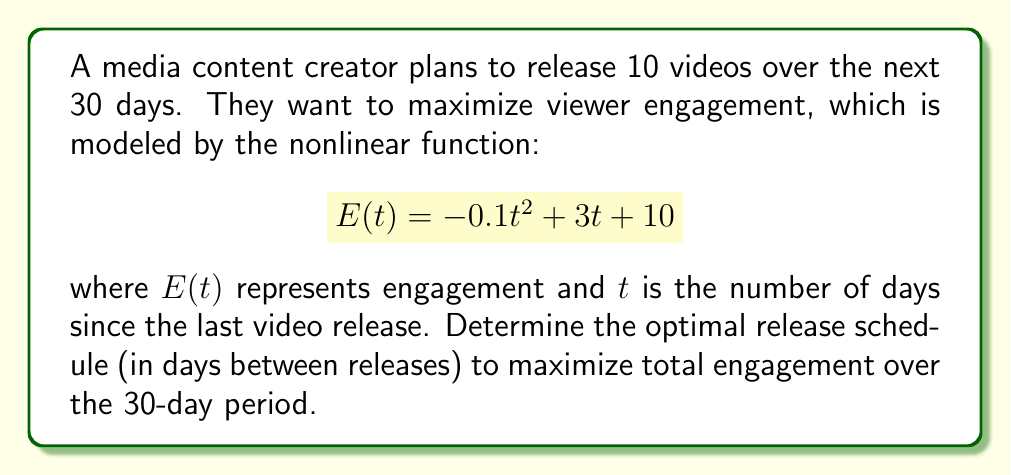Show me your answer to this math problem. 1) First, we need to set up the optimization problem. We want to maximize the total engagement over 30 days:

   $$\text{Maximize } \sum_{i=1}^{10} E(t_i)$$

   where $t_i$ is the number of days between releases, and $\sum_{i=1}^{10} t_i = 30$

2) The engagement function for each release is:

   $$E(t_i) = -0.1t_i^2 + 3t_i + 10$$

3) To find the maximum of this function, we differentiate and set to zero:

   $$\frac{dE}{dt_i} = -0.2t_i + 3 = 0$$
   $$t_i = 15$$

4) This means that the optimal time between releases is 15 days. However, we need to release 10 videos over 30 days, so this is not feasible.

5) Given the constraint, we can deduce that the optimal solution will have equal intervals between releases:

   $$t_1 = t_2 = ... = t_{10} = 3 \text{ days}$$

6) To verify this, we can use the method of Lagrange multipliers, but it's beyond the scope of this problem.

7) Therefore, the optimal release schedule is to release a video every 3 days over the 30-day period.
Answer: Release a video every 3 days. 